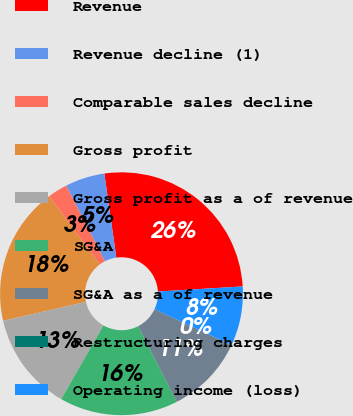Convert chart to OTSL. <chart><loc_0><loc_0><loc_500><loc_500><pie_chart><fcel>Revenue<fcel>Revenue decline (1)<fcel>Comparable sales decline<fcel>Gross profit<fcel>Gross profit as a of revenue<fcel>SG&A<fcel>SG&A as a of revenue<fcel>Restructuring charges<fcel>Operating income (loss)<nl><fcel>26.31%<fcel>5.27%<fcel>2.64%<fcel>18.42%<fcel>13.16%<fcel>15.79%<fcel>10.53%<fcel>0.01%<fcel>7.9%<nl></chart> 